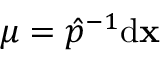<formula> <loc_0><loc_0><loc_500><loc_500>\mu = \hat { p } ^ { - 1 } \mathrm d \mathbf x</formula> 